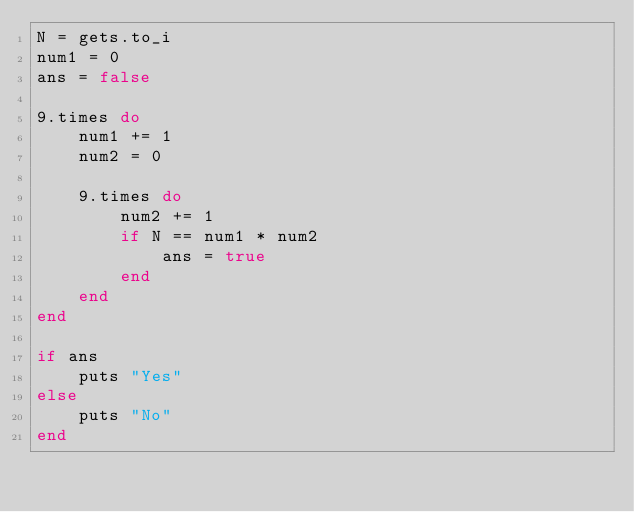Convert code to text. <code><loc_0><loc_0><loc_500><loc_500><_Ruby_>N = gets.to_i
num1 = 0
ans = false

9.times do
    num1 += 1
    num2 = 0

    9.times do
        num2 += 1
        if N == num1 * num2
            ans = true
        end
    end
end

if ans
    puts "Yes"
else
    puts "No"
end
</code> 